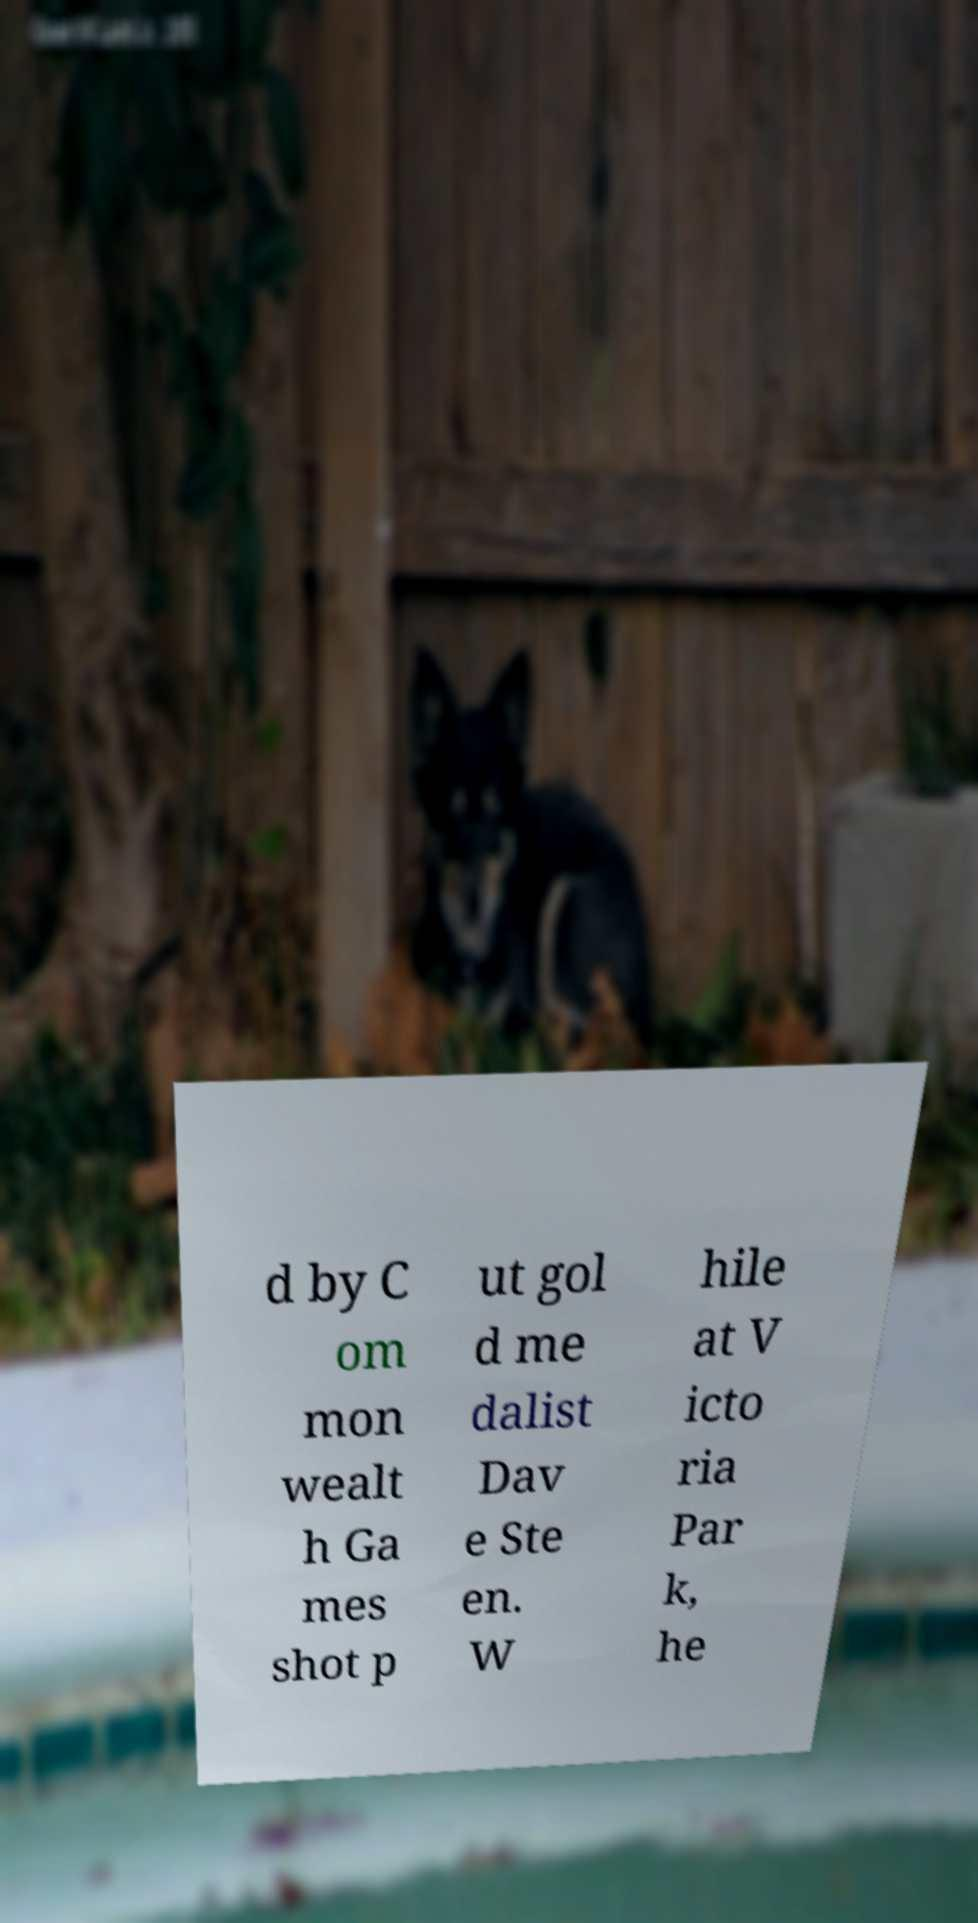I need the written content from this picture converted into text. Can you do that? d by C om mon wealt h Ga mes shot p ut gol d me dalist Dav e Ste en. W hile at V icto ria Par k, he 